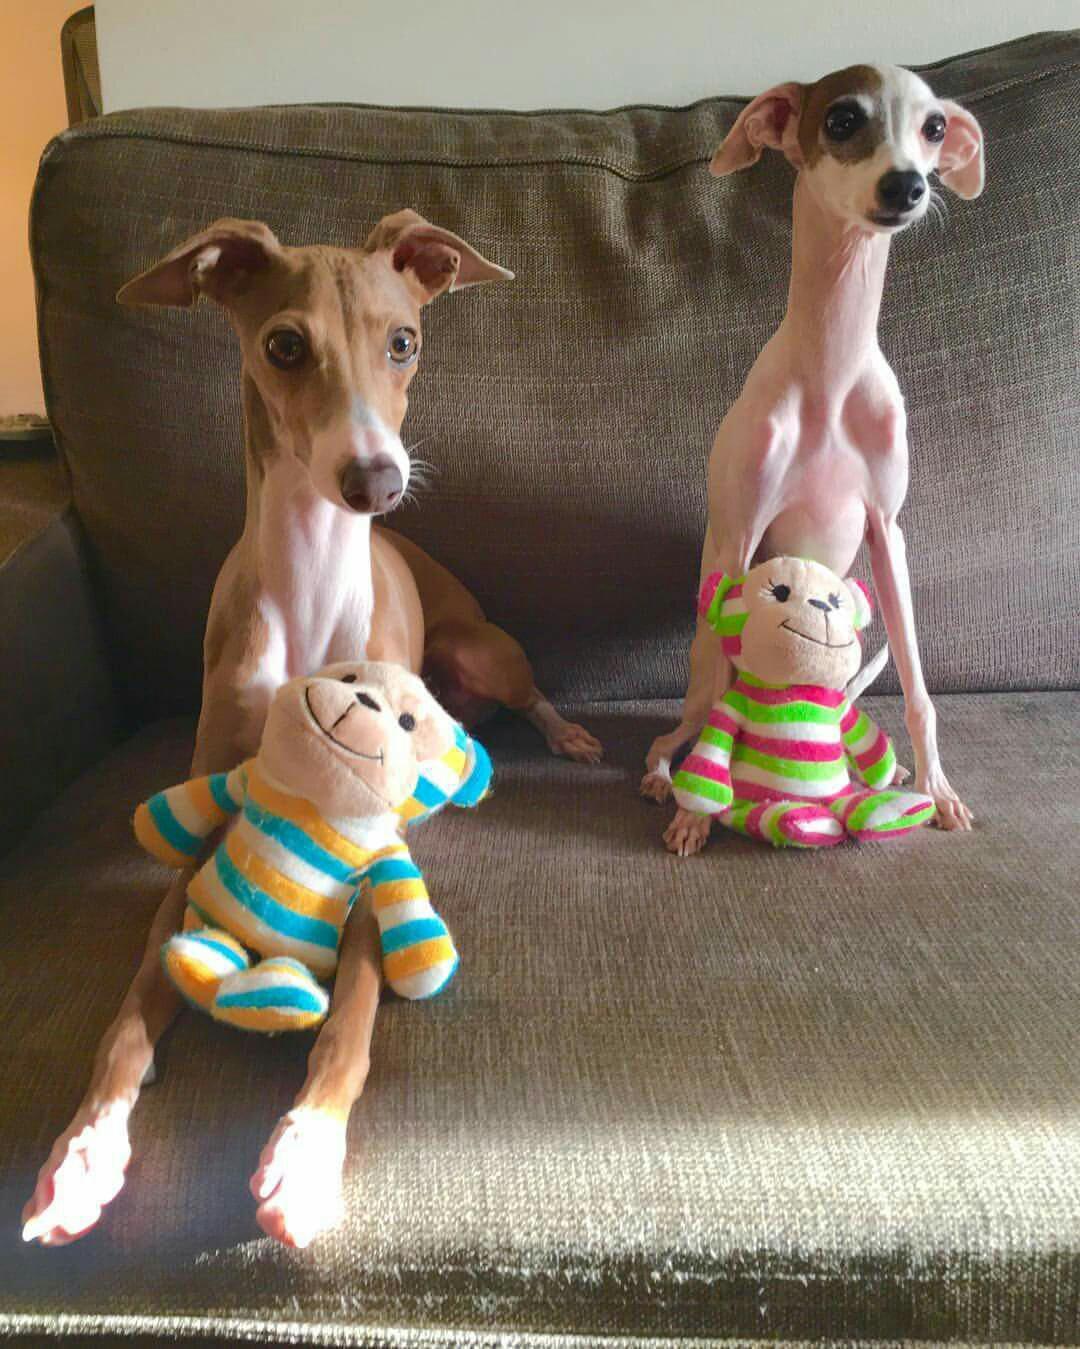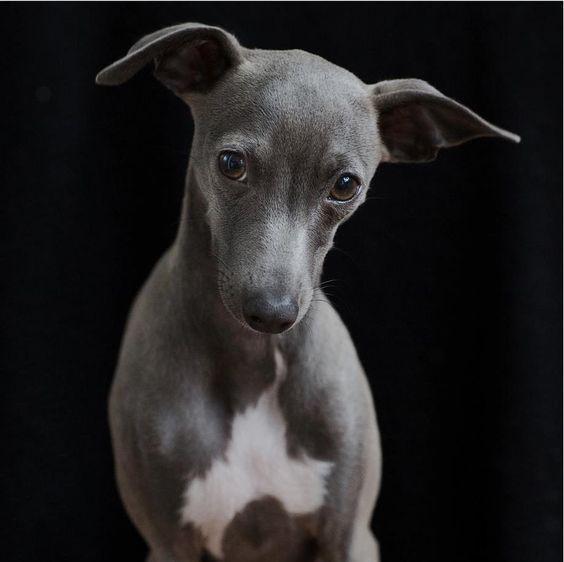The first image is the image on the left, the second image is the image on the right. For the images shown, is this caption "One image shows one brown dog reclining, and the other image features a hound wearing a collar." true? Answer yes or no. No. The first image is the image on the left, the second image is the image on the right. For the images displayed, is the sentence "There is three dogs." factually correct? Answer yes or no. Yes. 